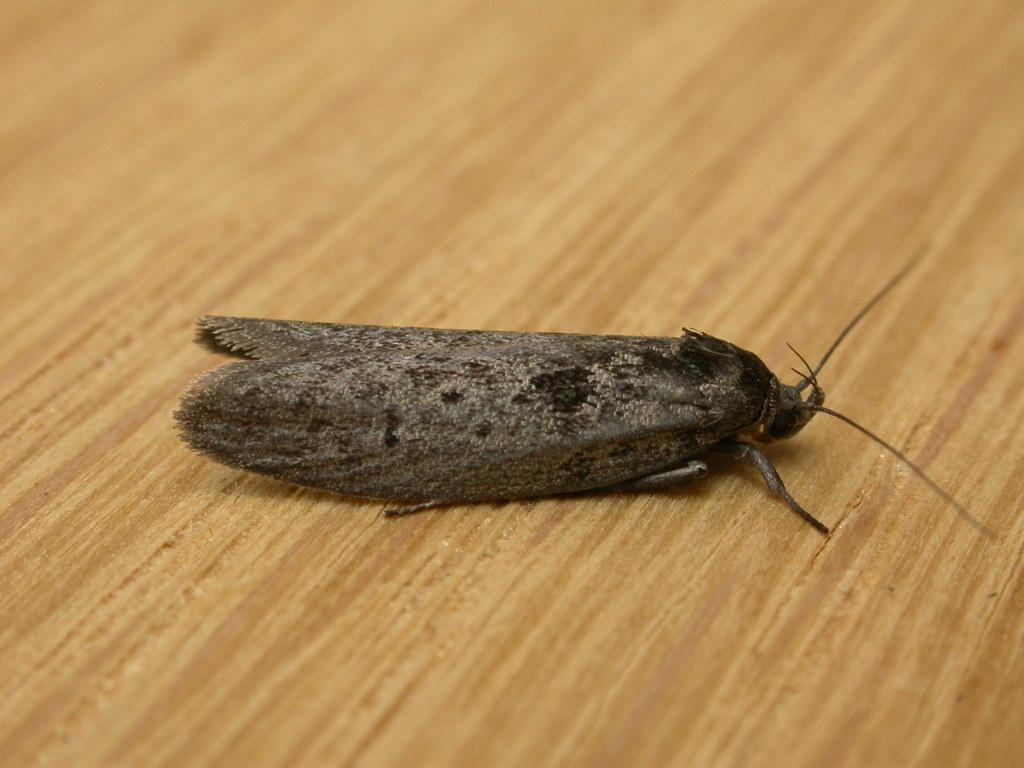What type of creature can be seen in the image? There is an insect in the image. What type of trail does the oatmeal leave behind in the image? There is no oatmeal present in the image, and therefore no trail can be observed. 